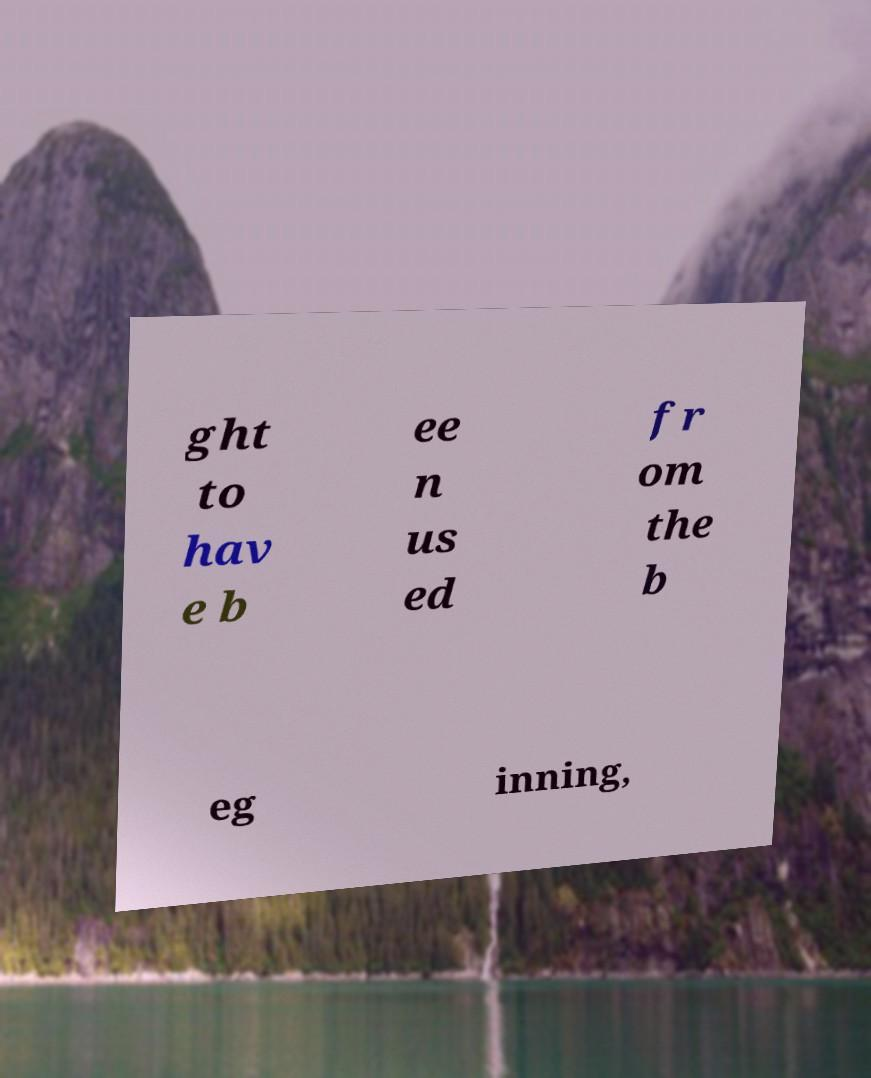Can you accurately transcribe the text from the provided image for me? ght to hav e b ee n us ed fr om the b eg inning, 